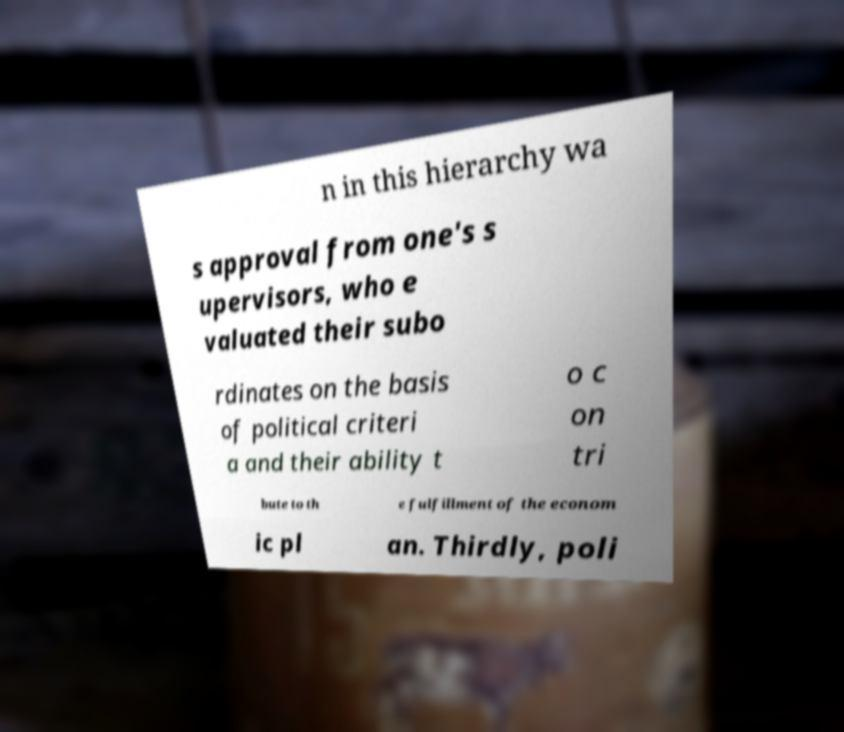I need the written content from this picture converted into text. Can you do that? n in this hierarchy wa s approval from one's s upervisors, who e valuated their subo rdinates on the basis of political criteri a and their ability t o c on tri bute to th e fulfillment of the econom ic pl an. Thirdly, poli 